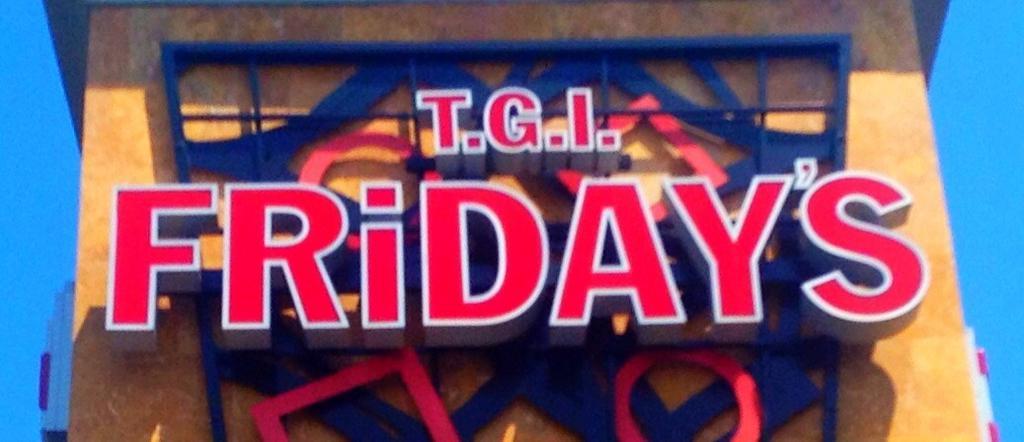How would you summarize this image in a sentence or two? In this image there is a building having some text on the wall. Background there is sky. 